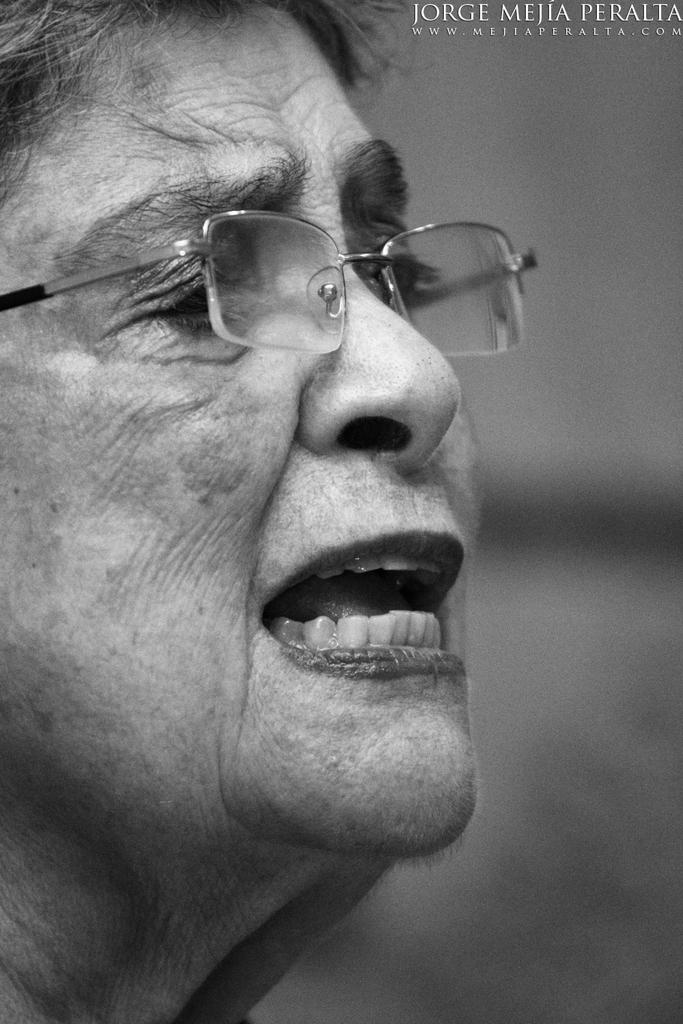What can be seen in the image? There is a person in the image. Can you describe the person's appearance? The person is wearing spectacles. How would you describe the background of the image? The background of the image is blurry. What is the color scheme of the image? The image is black and white. What type of skirt is the kitty wearing in the image? There is no kitty present in the image, and therefore no skirt can be observed. 